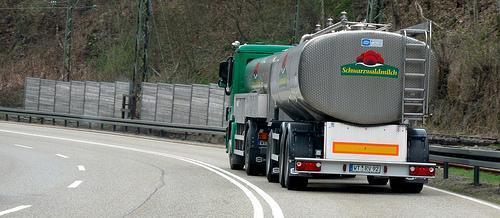How many trucks are there?
Give a very brief answer. 1. 